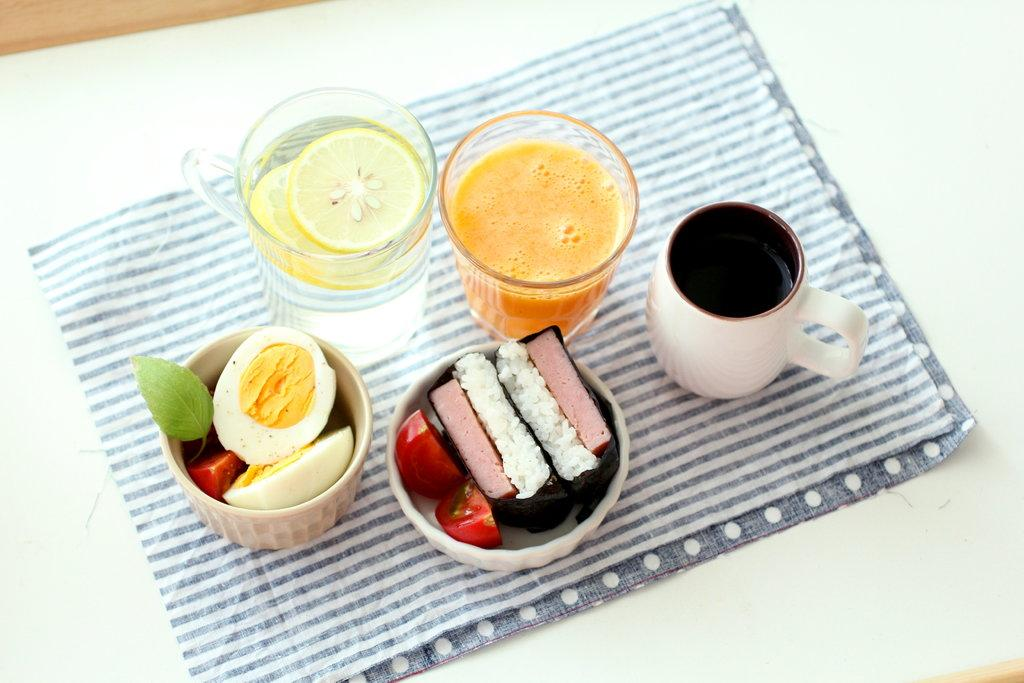How many cups full of food are visible in the image? There are 2 cups full of food in the image. What other type of container is present in the image? There are 2 glasses in the image. Can you describe the contents of one of the cups? One of the cups is full of liquids. What type of harmony can be heard between the cups and chairs in the image? There are no chairs present in the image, and therefore no harmony between the cups and chairs can be observed. 